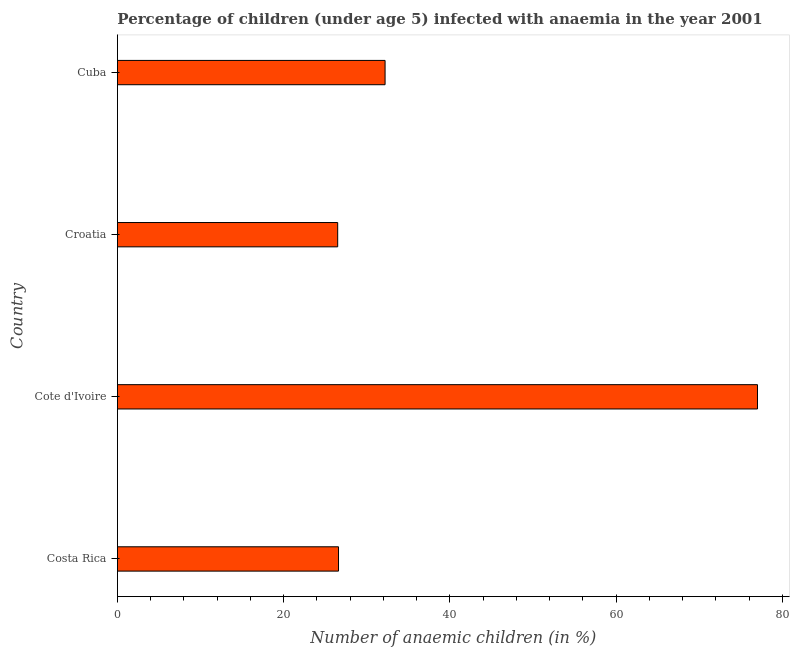What is the title of the graph?
Your response must be concise. Percentage of children (under age 5) infected with anaemia in the year 2001. What is the label or title of the X-axis?
Make the answer very short. Number of anaemic children (in %). What is the label or title of the Y-axis?
Your response must be concise. Country. In which country was the number of anaemic children maximum?
Offer a terse response. Cote d'Ivoire. In which country was the number of anaemic children minimum?
Your response must be concise. Croatia. What is the sum of the number of anaemic children?
Provide a succinct answer. 162.3. What is the average number of anaemic children per country?
Your response must be concise. 40.58. What is the median number of anaemic children?
Offer a terse response. 29.4. In how many countries, is the number of anaemic children greater than 52 %?
Provide a short and direct response. 1. What is the ratio of the number of anaemic children in Costa Rica to that in Cuba?
Provide a succinct answer. 0.83. Is the difference between the number of anaemic children in Costa Rica and Croatia greater than the difference between any two countries?
Provide a succinct answer. No. What is the difference between the highest and the second highest number of anaemic children?
Keep it short and to the point. 44.8. Is the sum of the number of anaemic children in Cote d'Ivoire and Cuba greater than the maximum number of anaemic children across all countries?
Your answer should be very brief. Yes. What is the difference between the highest and the lowest number of anaemic children?
Offer a very short reply. 50.5. Are all the bars in the graph horizontal?
Your response must be concise. Yes. How many countries are there in the graph?
Keep it short and to the point. 4. What is the difference between two consecutive major ticks on the X-axis?
Keep it short and to the point. 20. Are the values on the major ticks of X-axis written in scientific E-notation?
Offer a very short reply. No. What is the Number of anaemic children (in %) of Costa Rica?
Give a very brief answer. 26.6. What is the Number of anaemic children (in %) in Cote d'Ivoire?
Make the answer very short. 77. What is the Number of anaemic children (in %) in Croatia?
Keep it short and to the point. 26.5. What is the Number of anaemic children (in %) in Cuba?
Your response must be concise. 32.2. What is the difference between the Number of anaemic children (in %) in Costa Rica and Cote d'Ivoire?
Your answer should be compact. -50.4. What is the difference between the Number of anaemic children (in %) in Costa Rica and Cuba?
Provide a succinct answer. -5.6. What is the difference between the Number of anaemic children (in %) in Cote d'Ivoire and Croatia?
Provide a succinct answer. 50.5. What is the difference between the Number of anaemic children (in %) in Cote d'Ivoire and Cuba?
Offer a terse response. 44.8. What is the ratio of the Number of anaemic children (in %) in Costa Rica to that in Cote d'Ivoire?
Provide a succinct answer. 0.34. What is the ratio of the Number of anaemic children (in %) in Costa Rica to that in Cuba?
Offer a very short reply. 0.83. What is the ratio of the Number of anaemic children (in %) in Cote d'Ivoire to that in Croatia?
Make the answer very short. 2.91. What is the ratio of the Number of anaemic children (in %) in Cote d'Ivoire to that in Cuba?
Offer a terse response. 2.39. What is the ratio of the Number of anaemic children (in %) in Croatia to that in Cuba?
Give a very brief answer. 0.82. 